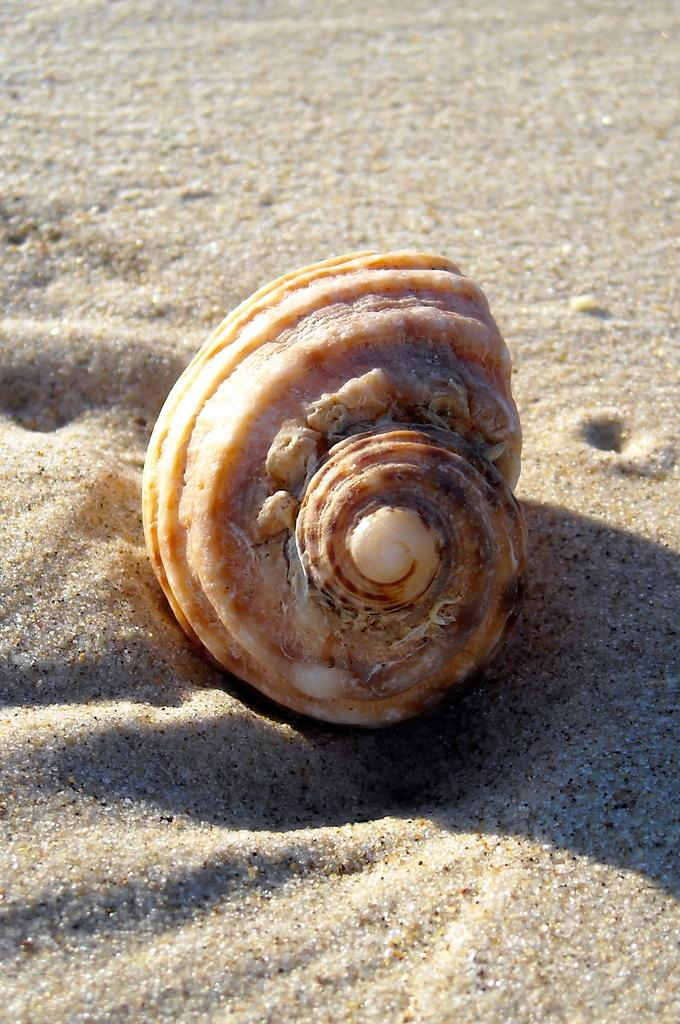What is the main object in the image? There is a shell in the image. Where is the shell located? The shell is on the sand. What type of minute is visible on the desk in the image? There is no desk or minute present in the image; it features a shell on the sand. What kind of cub can be seen interacting with the shell in the image? There is no cub present in the image; it only features a shell on the sand. 